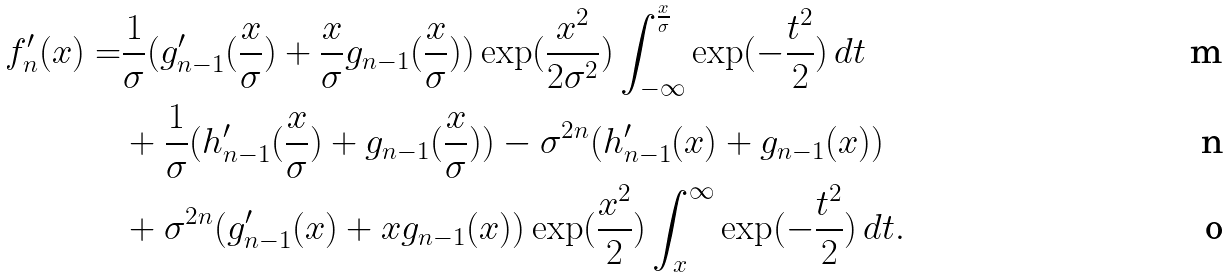<formula> <loc_0><loc_0><loc_500><loc_500>f _ { n } ^ { \prime } ( x ) = & \frac { 1 } { \sigma } ( g _ { n - 1 } ^ { \prime } ( \frac { x } { \sigma } ) + \frac { x } { \sigma } g _ { n - 1 } ( \frac { x } { \sigma } ) ) \exp ( \frac { x ^ { 2 } } { 2 \sigma ^ { 2 } } ) \int _ { - \infty } ^ { \frac { x } { \sigma } } \exp ( - \frac { t ^ { 2 } } { 2 } ) \, d t \\ & + \frac { 1 } { \sigma } ( h _ { n - 1 } ^ { \prime } ( \frac { x } { \sigma } ) + g _ { n - 1 } ( \frac { x } { \sigma } ) ) - \sigma ^ { 2 n } ( h _ { n - 1 } ^ { \prime } ( x ) + g _ { n - 1 } ( x ) ) \\ & + \sigma ^ { 2 n } ( g _ { n - 1 } ^ { \prime } ( x ) + x g _ { n - 1 } ( x ) ) \exp ( \frac { x ^ { 2 } } { 2 } ) \int _ { x } ^ { \infty } \exp ( - \frac { t ^ { 2 } } { 2 } ) \, d t .</formula> 